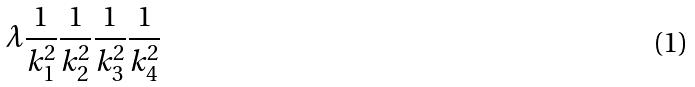<formula> <loc_0><loc_0><loc_500><loc_500>\lambda \frac { 1 } { k _ { 1 } ^ { 2 } } \frac { 1 } { k _ { 2 } ^ { 2 } } \frac { 1 } { k _ { 3 } ^ { 2 } } \frac { 1 } { k _ { 4 } ^ { 2 } }</formula> 